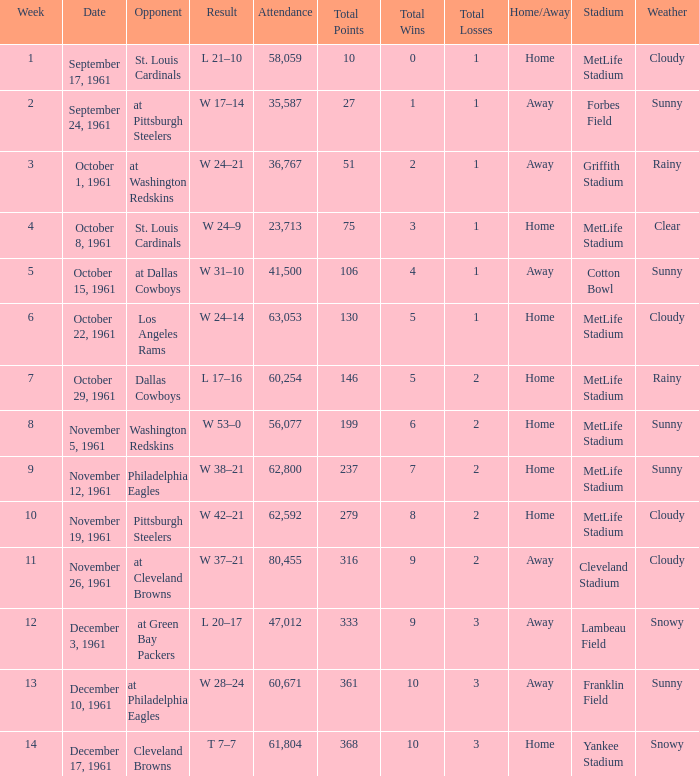What was the result on october 8, 1961? W 24–9. 